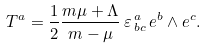<formula> <loc_0><loc_0><loc_500><loc_500>T ^ { a } = \frac { 1 } { 2 } \frac { m \mu + \Lambda } { m - \mu } \, \varepsilon _ { \, b c } ^ { \, a } \, e ^ { b } \wedge e ^ { c } .</formula> 